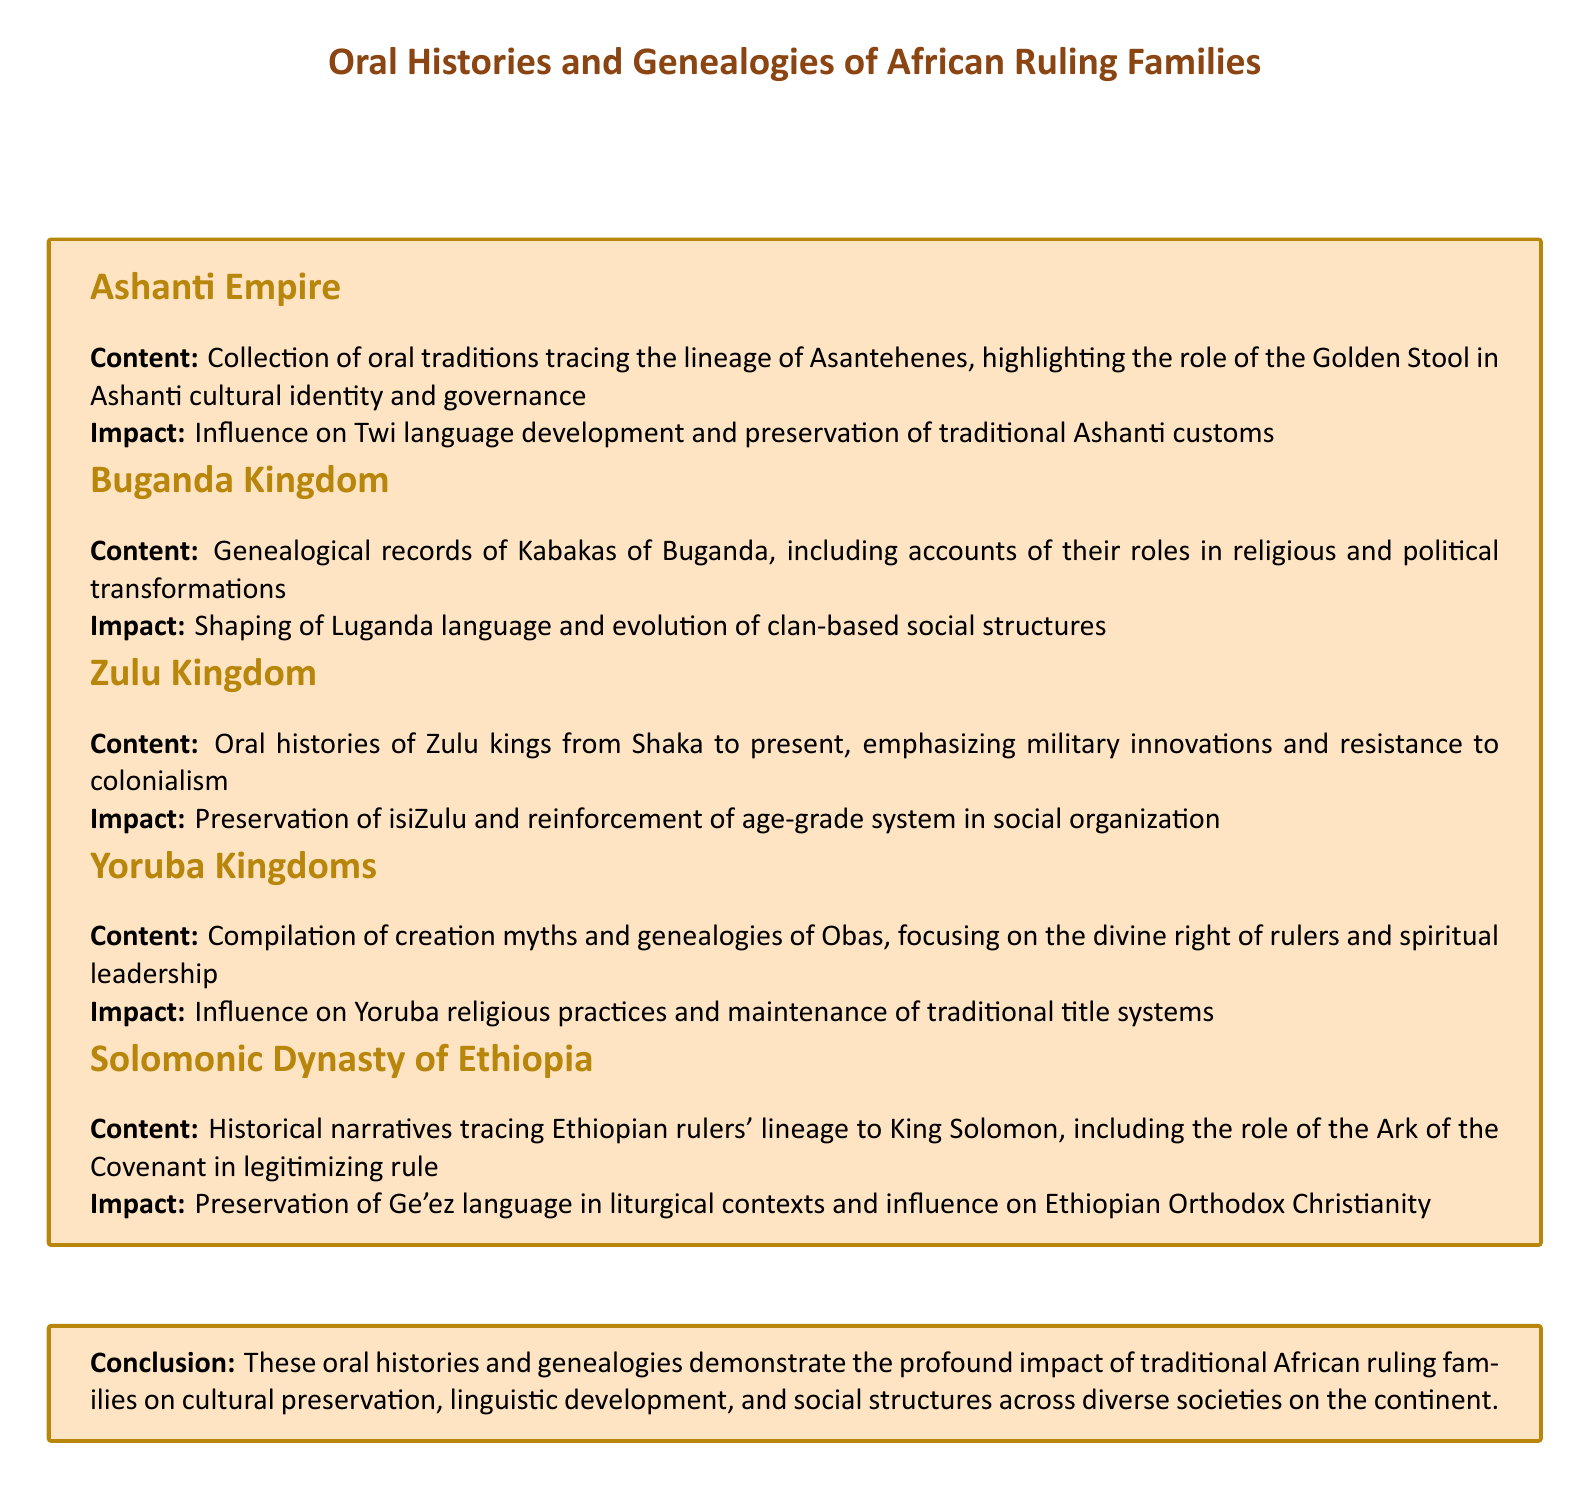What is the role of the Golden Stool in the Ashanti Empire? The document states that the Golden Stool plays a crucial role in Ashanti cultural identity and governance.
Answer: Governance What language is influenced by the genealogies of the Kabakas of Buganda? The genealogies of the Kabakas impact the Luganda language, as mentioned in the document.
Answer: Luganda Who are traced in the oral histories of the Zulu Kingdom? The oral histories trace Zulu kings, specifically from Shaka to the present.
Answer: Zulu kings What mythological element is associated with the Yoruba Kingdoms? The compilation includes creation myths that are linked to the Obas.
Answer: Creation myths What historical figure is the Solomonic Dynasty of Ethiopia connected to? The document mentions that the Solomonic Dynasty traces its lineage to King Solomon.
Answer: King Solomon What significant impact do traditional rulers have according to the conclusion? The conclusion highlights the impact of traditional African ruling families on cultural preservation.
Answer: Cultural preservation How has the isiZulu language been preserved according to the Zulu Kingdom section? The preservation of isiZulu is emphasized through the reinforcement of the age-grade system.
Answer: Age-grade system What type of governance is mentioned in relation to the Ashanti Empire? The governance type in the Ashanti Empire is described as traditional governance.
Answer: Traditional governance What type of leadership is emphasized in Yoruba genealogies? The document notes the emphasis on spiritual leadership linked to the divine right of rulers.
Answer: Spiritual leadership 